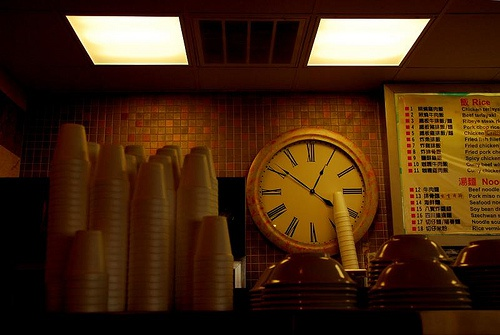Describe the objects in this image and their specific colors. I can see clock in black, olive, and maroon tones, bowl in black, maroon, and olive tones, bowl in black, maroon, and olive tones, cup in maroon and black tones, and cup in black, maroon, and olive tones in this image. 